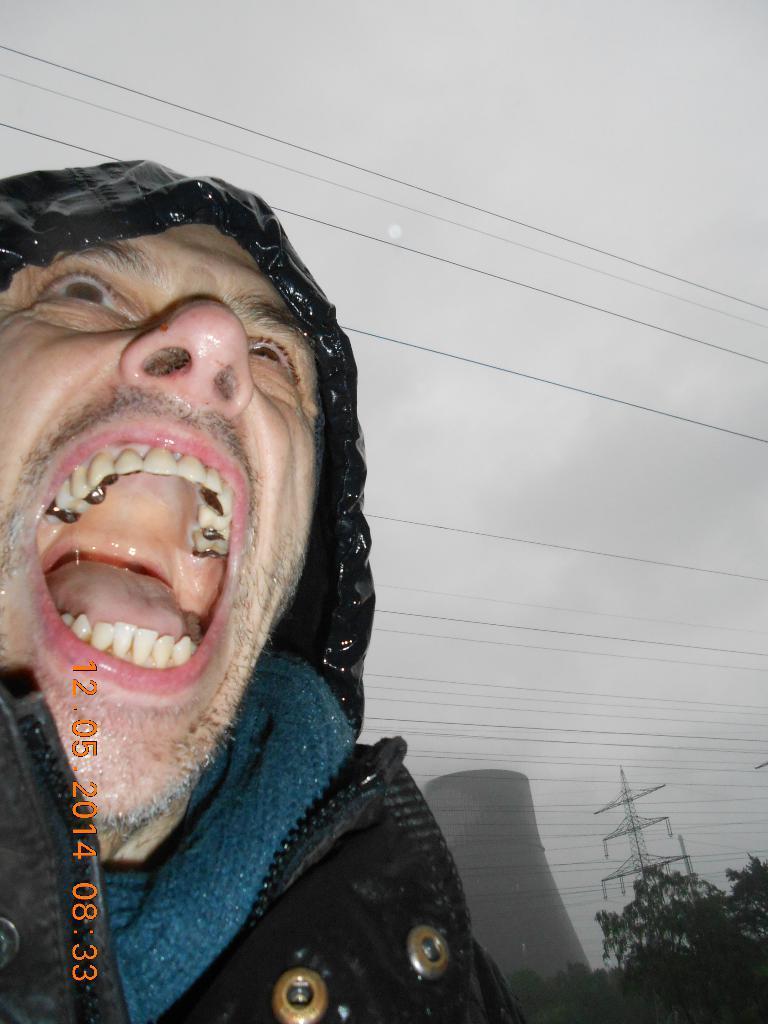Could you give a brief overview of what you see in this image? There is a man on the left side of this image. We can see trees and towers in the bottom right corner of this image and the sky is in the background. 